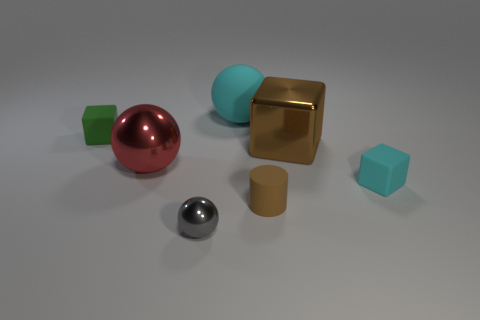Is there any other thing of the same color as the large shiny cube?
Provide a succinct answer. Yes. What size is the brown object that is the same material as the cyan block?
Make the answer very short. Small. What number of tiny things are either gray metal balls or metal cylinders?
Make the answer very short. 1. What is the size of the ball behind the small rubber cube to the left of the tiny thing that is right of the small cylinder?
Offer a very short reply. Large. What number of cyan matte objects are the same size as the cyan matte sphere?
Your answer should be very brief. 0. What number of things are either small green rubber things or metal things that are on the right side of the cylinder?
Keep it short and to the point. 2. What is the shape of the big cyan matte thing?
Offer a terse response. Sphere. Is the small metal ball the same color as the metallic block?
Make the answer very short. No. The cube that is the same size as the matte ball is what color?
Provide a short and direct response. Brown. How many cyan objects are either tiny metal things or small matte cubes?
Make the answer very short. 1. 